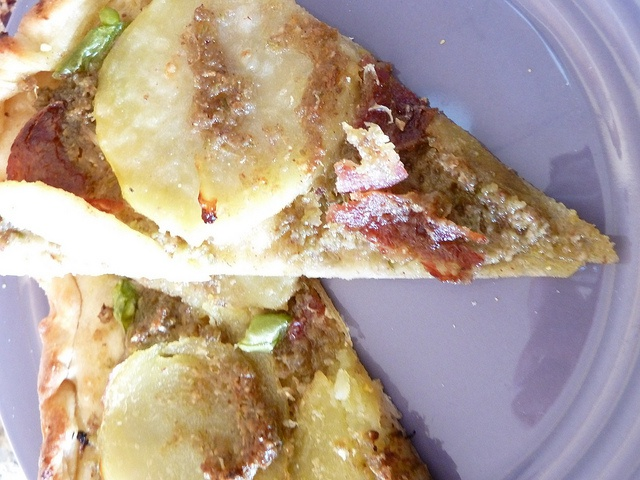Describe the objects in this image and their specific colors. I can see pizza in lightpink, ivory, khaki, gray, and tan tones and pizza in lightpink, tan, and beige tones in this image. 